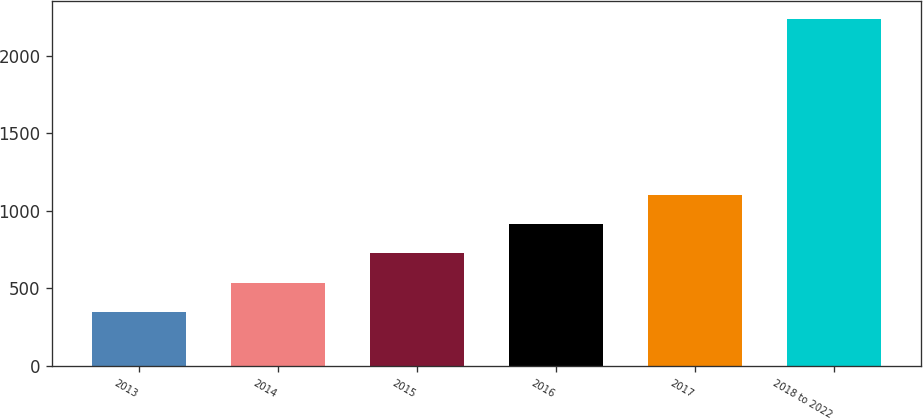Convert chart. <chart><loc_0><loc_0><loc_500><loc_500><bar_chart><fcel>2013<fcel>2014<fcel>2015<fcel>2016<fcel>2017<fcel>2018 to 2022<nl><fcel>347<fcel>536.1<fcel>725.2<fcel>914.3<fcel>1103.4<fcel>2238<nl></chart> 